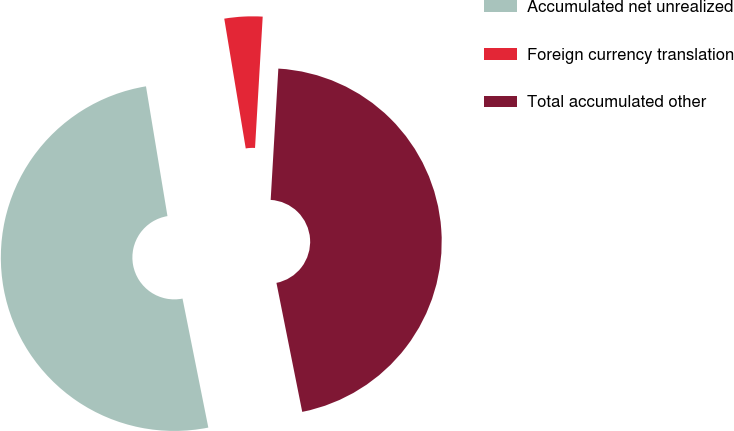<chart> <loc_0><loc_0><loc_500><loc_500><pie_chart><fcel>Accumulated net unrealized<fcel>Foreign currency translation<fcel>Total accumulated other<nl><fcel>50.53%<fcel>3.54%<fcel>45.93%<nl></chart> 